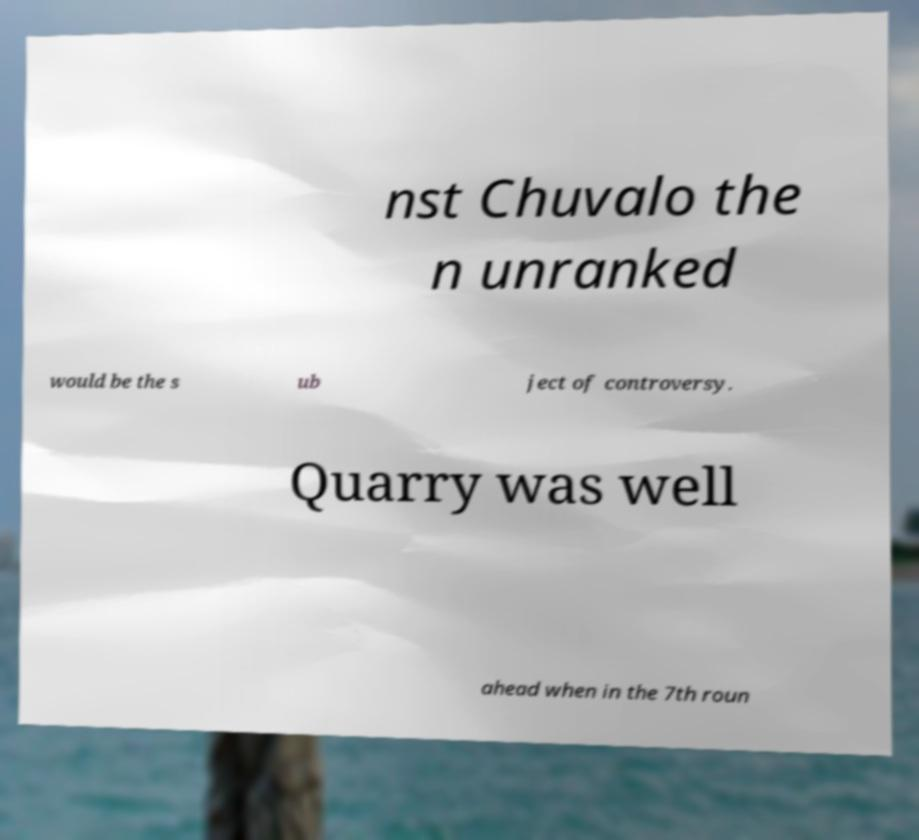For documentation purposes, I need the text within this image transcribed. Could you provide that? nst Chuvalo the n unranked would be the s ub ject of controversy. Quarry was well ahead when in the 7th roun 